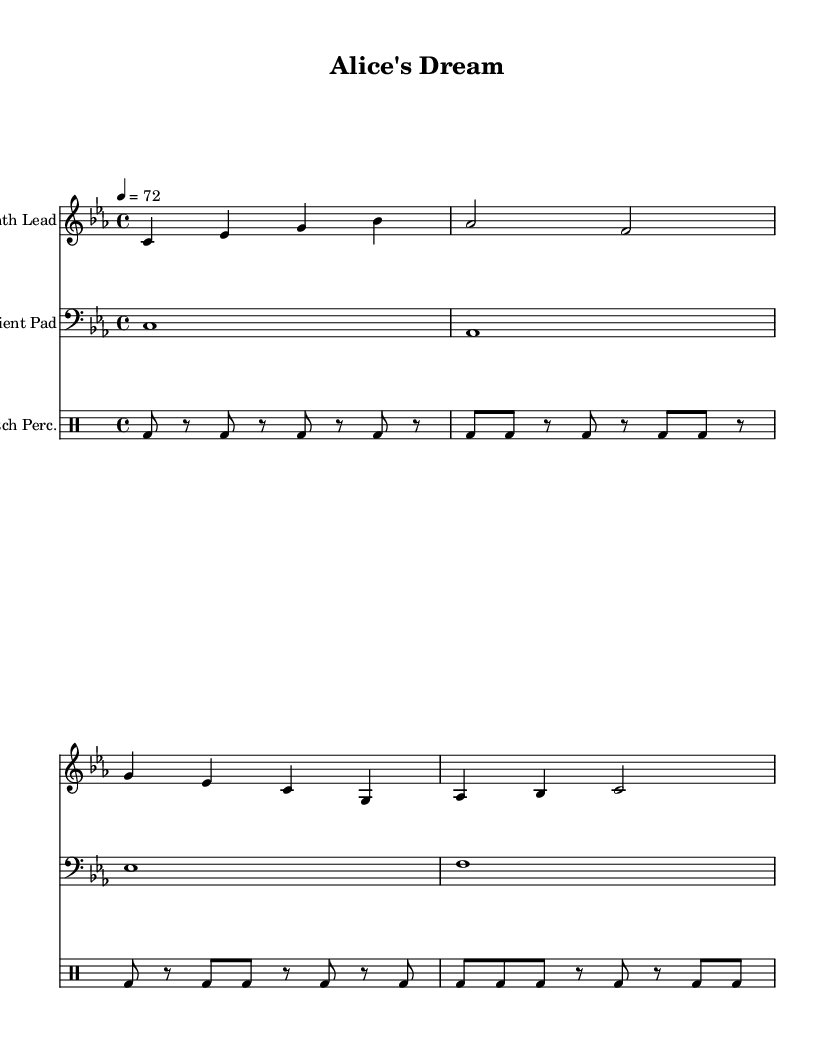What is the key signature of this music? The key signature is indicated at the beginning of the staff, showing that it is in C minor, which has three flats (B flat, E flat, and A flat).
Answer: C minor What is the time signature of the piece? The time signature in the piece is found at the beginning, which shows it is written in 4/4 time, meaning there are four beats in each measure.
Answer: 4/4 What is the tempo marking of this composition? The tempo marking is located at the start of the score, where it indicates the speed as 4 equals 72 beats per minute.
Answer: 72 How many measures are in the synth lead part? Counting the measures in the synth lead notation shows that there are a total of four distinct measures.
Answer: 4 What type of percussion is used in this composition? The percussion section is specified in the title of the staff, where it states "Glitch Perc." indicating a glitch-style percussion is employed, typical for electronic music.
Answer: Glitch What is the primary instrument for the melody? Looking at the staff labeled "Synth Lead," it shows that the primary melodic instrument is a synthesizer, which is commonly used in electronic music to create lead sounds.
Answer: Synthesizer Which musical element is used to create atmosphere in the piece? By examining the "Ambient Pad" staff, it is evident that the ambient pad is responsible for creating a lush, atmospheric sound, a characteristic feature in experimental electronic compositions.
Answer: Ambient Pad 